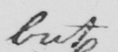Can you read and transcribe this handwriting? but 